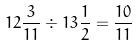<formula> <loc_0><loc_0><loc_500><loc_500>1 2 \frac { 3 } { 1 1 } \div 1 3 \frac { 1 } { 2 } = \frac { 1 0 } { 1 1 }</formula> 